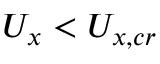Convert formula to latex. <formula><loc_0><loc_0><loc_500><loc_500>U _ { x } < U _ { x , c r }</formula> 